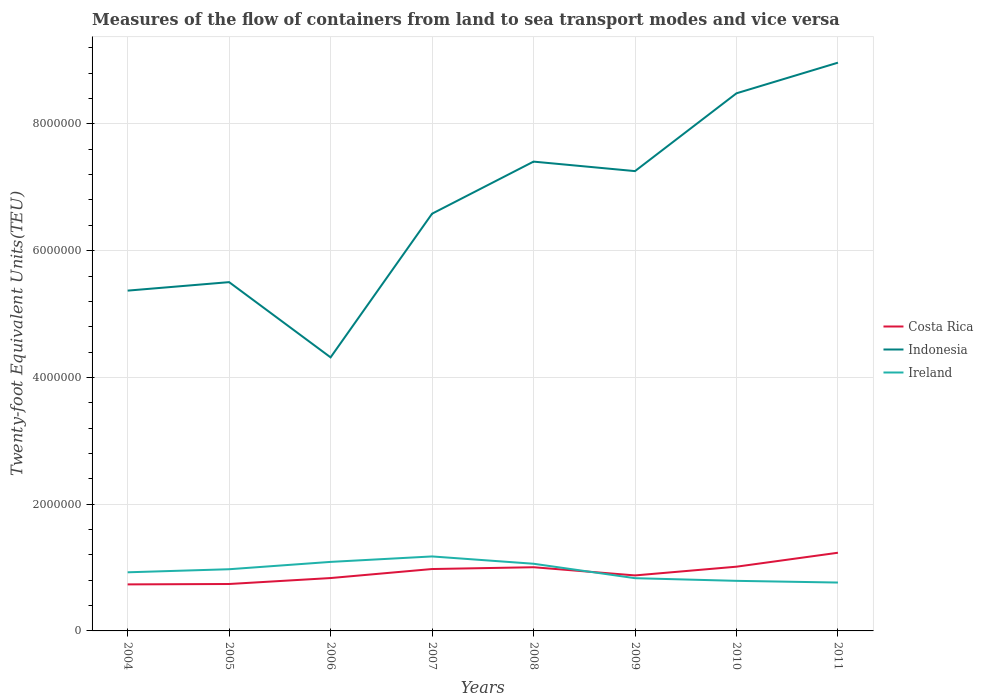How many different coloured lines are there?
Make the answer very short. 3. Across all years, what is the maximum container port traffic in Ireland?
Provide a succinct answer. 7.63e+05. In which year was the container port traffic in Indonesia maximum?
Your response must be concise. 2006. What is the total container port traffic in Indonesia in the graph?
Give a very brief answer. -2.27e+06. What is the difference between the highest and the second highest container port traffic in Indonesia?
Provide a short and direct response. 4.65e+06. What is the difference between the highest and the lowest container port traffic in Indonesia?
Give a very brief answer. 4. How many years are there in the graph?
Offer a terse response. 8. What is the difference between two consecutive major ticks on the Y-axis?
Make the answer very short. 2.00e+06. Does the graph contain grids?
Ensure brevity in your answer.  Yes. Where does the legend appear in the graph?
Provide a succinct answer. Center right. How many legend labels are there?
Offer a very short reply. 3. How are the legend labels stacked?
Keep it short and to the point. Vertical. What is the title of the graph?
Offer a terse response. Measures of the flow of containers from land to sea transport modes and vice versa. Does "Colombia" appear as one of the legend labels in the graph?
Offer a terse response. No. What is the label or title of the X-axis?
Your answer should be compact. Years. What is the label or title of the Y-axis?
Your answer should be compact. Twenty-foot Equivalent Units(TEU). What is the Twenty-foot Equivalent Units(TEU) of Costa Rica in 2004?
Ensure brevity in your answer.  7.34e+05. What is the Twenty-foot Equivalent Units(TEU) of Indonesia in 2004?
Offer a terse response. 5.37e+06. What is the Twenty-foot Equivalent Units(TEU) in Ireland in 2004?
Make the answer very short. 9.25e+05. What is the Twenty-foot Equivalent Units(TEU) in Costa Rica in 2005?
Offer a terse response. 7.40e+05. What is the Twenty-foot Equivalent Units(TEU) in Indonesia in 2005?
Offer a terse response. 5.50e+06. What is the Twenty-foot Equivalent Units(TEU) in Ireland in 2005?
Make the answer very short. 9.73e+05. What is the Twenty-foot Equivalent Units(TEU) of Costa Rica in 2006?
Offer a terse response. 8.34e+05. What is the Twenty-foot Equivalent Units(TEU) of Indonesia in 2006?
Your response must be concise. 4.32e+06. What is the Twenty-foot Equivalent Units(TEU) of Ireland in 2006?
Offer a terse response. 1.09e+06. What is the Twenty-foot Equivalent Units(TEU) of Costa Rica in 2007?
Your answer should be compact. 9.77e+05. What is the Twenty-foot Equivalent Units(TEU) in Indonesia in 2007?
Offer a terse response. 6.58e+06. What is the Twenty-foot Equivalent Units(TEU) of Ireland in 2007?
Keep it short and to the point. 1.18e+06. What is the Twenty-foot Equivalent Units(TEU) of Costa Rica in 2008?
Make the answer very short. 1.00e+06. What is the Twenty-foot Equivalent Units(TEU) in Indonesia in 2008?
Make the answer very short. 7.40e+06. What is the Twenty-foot Equivalent Units(TEU) in Ireland in 2008?
Offer a very short reply. 1.06e+06. What is the Twenty-foot Equivalent Units(TEU) of Costa Rica in 2009?
Offer a terse response. 8.76e+05. What is the Twenty-foot Equivalent Units(TEU) in Indonesia in 2009?
Keep it short and to the point. 7.26e+06. What is the Twenty-foot Equivalent Units(TEU) of Ireland in 2009?
Make the answer very short. 8.32e+05. What is the Twenty-foot Equivalent Units(TEU) in Costa Rica in 2010?
Make the answer very short. 1.01e+06. What is the Twenty-foot Equivalent Units(TEU) in Indonesia in 2010?
Make the answer very short. 8.48e+06. What is the Twenty-foot Equivalent Units(TEU) of Ireland in 2010?
Your answer should be very brief. 7.90e+05. What is the Twenty-foot Equivalent Units(TEU) of Costa Rica in 2011?
Make the answer very short. 1.23e+06. What is the Twenty-foot Equivalent Units(TEU) of Indonesia in 2011?
Provide a succinct answer. 8.97e+06. What is the Twenty-foot Equivalent Units(TEU) in Ireland in 2011?
Provide a succinct answer. 7.63e+05. Across all years, what is the maximum Twenty-foot Equivalent Units(TEU) in Costa Rica?
Your answer should be compact. 1.23e+06. Across all years, what is the maximum Twenty-foot Equivalent Units(TEU) of Indonesia?
Give a very brief answer. 8.97e+06. Across all years, what is the maximum Twenty-foot Equivalent Units(TEU) of Ireland?
Your answer should be very brief. 1.18e+06. Across all years, what is the minimum Twenty-foot Equivalent Units(TEU) in Costa Rica?
Offer a very short reply. 7.34e+05. Across all years, what is the minimum Twenty-foot Equivalent Units(TEU) in Indonesia?
Make the answer very short. 4.32e+06. Across all years, what is the minimum Twenty-foot Equivalent Units(TEU) in Ireland?
Ensure brevity in your answer.  7.63e+05. What is the total Twenty-foot Equivalent Units(TEU) in Costa Rica in the graph?
Keep it short and to the point. 7.41e+06. What is the total Twenty-foot Equivalent Units(TEU) of Indonesia in the graph?
Ensure brevity in your answer.  5.39e+07. What is the total Twenty-foot Equivalent Units(TEU) in Ireland in the graph?
Keep it short and to the point. 7.61e+06. What is the difference between the Twenty-foot Equivalent Units(TEU) of Costa Rica in 2004 and that in 2005?
Provide a short and direct response. -6332. What is the difference between the Twenty-foot Equivalent Units(TEU) in Indonesia in 2004 and that in 2005?
Provide a short and direct response. -1.34e+05. What is the difference between the Twenty-foot Equivalent Units(TEU) of Ireland in 2004 and that in 2005?
Offer a very short reply. -4.84e+04. What is the difference between the Twenty-foot Equivalent Units(TEU) in Costa Rica in 2004 and that in 2006?
Provide a short and direct response. -1.00e+05. What is the difference between the Twenty-foot Equivalent Units(TEU) of Indonesia in 2004 and that in 2006?
Provide a short and direct response. 1.05e+06. What is the difference between the Twenty-foot Equivalent Units(TEU) of Ireland in 2004 and that in 2006?
Keep it short and to the point. -1.64e+05. What is the difference between the Twenty-foot Equivalent Units(TEU) in Costa Rica in 2004 and that in 2007?
Offer a very short reply. -2.43e+05. What is the difference between the Twenty-foot Equivalent Units(TEU) of Indonesia in 2004 and that in 2007?
Your response must be concise. -1.21e+06. What is the difference between the Twenty-foot Equivalent Units(TEU) of Ireland in 2004 and that in 2007?
Keep it short and to the point. -2.50e+05. What is the difference between the Twenty-foot Equivalent Units(TEU) of Costa Rica in 2004 and that in 2008?
Give a very brief answer. -2.71e+05. What is the difference between the Twenty-foot Equivalent Units(TEU) in Indonesia in 2004 and that in 2008?
Make the answer very short. -2.04e+06. What is the difference between the Twenty-foot Equivalent Units(TEU) of Ireland in 2004 and that in 2008?
Your answer should be compact. -1.35e+05. What is the difference between the Twenty-foot Equivalent Units(TEU) of Costa Rica in 2004 and that in 2009?
Your answer should be very brief. -1.42e+05. What is the difference between the Twenty-foot Equivalent Units(TEU) in Indonesia in 2004 and that in 2009?
Ensure brevity in your answer.  -1.89e+06. What is the difference between the Twenty-foot Equivalent Units(TEU) of Ireland in 2004 and that in 2009?
Provide a short and direct response. 9.29e+04. What is the difference between the Twenty-foot Equivalent Units(TEU) in Costa Rica in 2004 and that in 2010?
Provide a succinct answer. -2.79e+05. What is the difference between the Twenty-foot Equivalent Units(TEU) of Indonesia in 2004 and that in 2010?
Ensure brevity in your answer.  -3.11e+06. What is the difference between the Twenty-foot Equivalent Units(TEU) of Ireland in 2004 and that in 2010?
Your answer should be compact. 1.35e+05. What is the difference between the Twenty-foot Equivalent Units(TEU) in Costa Rica in 2004 and that in 2011?
Provide a short and direct response. -4.99e+05. What is the difference between the Twenty-foot Equivalent Units(TEU) of Indonesia in 2004 and that in 2011?
Your answer should be compact. -3.60e+06. What is the difference between the Twenty-foot Equivalent Units(TEU) in Ireland in 2004 and that in 2011?
Make the answer very short. 1.62e+05. What is the difference between the Twenty-foot Equivalent Units(TEU) in Costa Rica in 2005 and that in 2006?
Give a very brief answer. -9.39e+04. What is the difference between the Twenty-foot Equivalent Units(TEU) of Indonesia in 2005 and that in 2006?
Make the answer very short. 1.19e+06. What is the difference between the Twenty-foot Equivalent Units(TEU) of Ireland in 2005 and that in 2006?
Keep it short and to the point. -1.16e+05. What is the difference between the Twenty-foot Equivalent Units(TEU) of Costa Rica in 2005 and that in 2007?
Give a very brief answer. -2.36e+05. What is the difference between the Twenty-foot Equivalent Units(TEU) in Indonesia in 2005 and that in 2007?
Your response must be concise. -1.08e+06. What is the difference between the Twenty-foot Equivalent Units(TEU) in Ireland in 2005 and that in 2007?
Your answer should be compact. -2.02e+05. What is the difference between the Twenty-foot Equivalent Units(TEU) in Costa Rica in 2005 and that in 2008?
Make the answer very short. -2.65e+05. What is the difference between the Twenty-foot Equivalent Units(TEU) in Indonesia in 2005 and that in 2008?
Your answer should be compact. -1.90e+06. What is the difference between the Twenty-foot Equivalent Units(TEU) of Ireland in 2005 and that in 2008?
Give a very brief answer. -8.67e+04. What is the difference between the Twenty-foot Equivalent Units(TEU) of Costa Rica in 2005 and that in 2009?
Keep it short and to the point. -1.35e+05. What is the difference between the Twenty-foot Equivalent Units(TEU) in Indonesia in 2005 and that in 2009?
Ensure brevity in your answer.  -1.75e+06. What is the difference between the Twenty-foot Equivalent Units(TEU) in Ireland in 2005 and that in 2009?
Provide a succinct answer. 1.41e+05. What is the difference between the Twenty-foot Equivalent Units(TEU) in Costa Rica in 2005 and that in 2010?
Your answer should be very brief. -2.73e+05. What is the difference between the Twenty-foot Equivalent Units(TEU) in Indonesia in 2005 and that in 2010?
Ensure brevity in your answer.  -2.98e+06. What is the difference between the Twenty-foot Equivalent Units(TEU) in Ireland in 2005 and that in 2010?
Your answer should be compact. 1.83e+05. What is the difference between the Twenty-foot Equivalent Units(TEU) of Costa Rica in 2005 and that in 2011?
Provide a short and direct response. -4.93e+05. What is the difference between the Twenty-foot Equivalent Units(TEU) in Indonesia in 2005 and that in 2011?
Offer a very short reply. -3.46e+06. What is the difference between the Twenty-foot Equivalent Units(TEU) of Ireland in 2005 and that in 2011?
Provide a short and direct response. 2.10e+05. What is the difference between the Twenty-foot Equivalent Units(TEU) of Costa Rica in 2006 and that in 2007?
Your response must be concise. -1.42e+05. What is the difference between the Twenty-foot Equivalent Units(TEU) in Indonesia in 2006 and that in 2007?
Provide a short and direct response. -2.27e+06. What is the difference between the Twenty-foot Equivalent Units(TEU) of Ireland in 2006 and that in 2007?
Ensure brevity in your answer.  -8.59e+04. What is the difference between the Twenty-foot Equivalent Units(TEU) in Costa Rica in 2006 and that in 2008?
Your answer should be very brief. -1.71e+05. What is the difference between the Twenty-foot Equivalent Units(TEU) of Indonesia in 2006 and that in 2008?
Ensure brevity in your answer.  -3.09e+06. What is the difference between the Twenty-foot Equivalent Units(TEU) of Ireland in 2006 and that in 2008?
Provide a succinct answer. 2.93e+04. What is the difference between the Twenty-foot Equivalent Units(TEU) of Costa Rica in 2006 and that in 2009?
Ensure brevity in your answer.  -4.14e+04. What is the difference between the Twenty-foot Equivalent Units(TEU) of Indonesia in 2006 and that in 2009?
Your answer should be compact. -2.94e+06. What is the difference between the Twenty-foot Equivalent Units(TEU) in Ireland in 2006 and that in 2009?
Provide a short and direct response. 2.57e+05. What is the difference between the Twenty-foot Equivalent Units(TEU) in Costa Rica in 2006 and that in 2010?
Provide a succinct answer. -1.79e+05. What is the difference between the Twenty-foot Equivalent Units(TEU) in Indonesia in 2006 and that in 2010?
Offer a very short reply. -4.17e+06. What is the difference between the Twenty-foot Equivalent Units(TEU) in Ireland in 2006 and that in 2010?
Make the answer very short. 2.99e+05. What is the difference between the Twenty-foot Equivalent Units(TEU) of Costa Rica in 2006 and that in 2011?
Keep it short and to the point. -3.99e+05. What is the difference between the Twenty-foot Equivalent Units(TEU) in Indonesia in 2006 and that in 2011?
Make the answer very short. -4.65e+06. What is the difference between the Twenty-foot Equivalent Units(TEU) of Ireland in 2006 and that in 2011?
Keep it short and to the point. 3.26e+05. What is the difference between the Twenty-foot Equivalent Units(TEU) in Costa Rica in 2007 and that in 2008?
Offer a terse response. -2.84e+04. What is the difference between the Twenty-foot Equivalent Units(TEU) of Indonesia in 2007 and that in 2008?
Make the answer very short. -8.22e+05. What is the difference between the Twenty-foot Equivalent Units(TEU) of Ireland in 2007 and that in 2008?
Your answer should be compact. 1.15e+05. What is the difference between the Twenty-foot Equivalent Units(TEU) of Costa Rica in 2007 and that in 2009?
Provide a short and direct response. 1.01e+05. What is the difference between the Twenty-foot Equivalent Units(TEU) of Indonesia in 2007 and that in 2009?
Give a very brief answer. -6.72e+05. What is the difference between the Twenty-foot Equivalent Units(TEU) of Ireland in 2007 and that in 2009?
Keep it short and to the point. 3.43e+05. What is the difference between the Twenty-foot Equivalent Units(TEU) of Costa Rica in 2007 and that in 2010?
Your answer should be compact. -3.69e+04. What is the difference between the Twenty-foot Equivalent Units(TEU) of Indonesia in 2007 and that in 2010?
Your response must be concise. -1.90e+06. What is the difference between the Twenty-foot Equivalent Units(TEU) in Ireland in 2007 and that in 2010?
Make the answer very short. 3.85e+05. What is the difference between the Twenty-foot Equivalent Units(TEU) in Costa Rica in 2007 and that in 2011?
Make the answer very short. -2.57e+05. What is the difference between the Twenty-foot Equivalent Units(TEU) of Indonesia in 2007 and that in 2011?
Provide a short and direct response. -2.38e+06. What is the difference between the Twenty-foot Equivalent Units(TEU) in Ireland in 2007 and that in 2011?
Keep it short and to the point. 4.12e+05. What is the difference between the Twenty-foot Equivalent Units(TEU) of Costa Rica in 2008 and that in 2009?
Offer a terse response. 1.29e+05. What is the difference between the Twenty-foot Equivalent Units(TEU) of Indonesia in 2008 and that in 2009?
Your answer should be compact. 1.50e+05. What is the difference between the Twenty-foot Equivalent Units(TEU) of Ireland in 2008 and that in 2009?
Your answer should be very brief. 2.28e+05. What is the difference between the Twenty-foot Equivalent Units(TEU) of Costa Rica in 2008 and that in 2010?
Make the answer very short. -8512. What is the difference between the Twenty-foot Equivalent Units(TEU) in Indonesia in 2008 and that in 2010?
Provide a short and direct response. -1.08e+06. What is the difference between the Twenty-foot Equivalent Units(TEU) of Ireland in 2008 and that in 2010?
Your response must be concise. 2.70e+05. What is the difference between the Twenty-foot Equivalent Units(TEU) of Costa Rica in 2008 and that in 2011?
Make the answer very short. -2.28e+05. What is the difference between the Twenty-foot Equivalent Units(TEU) in Indonesia in 2008 and that in 2011?
Offer a very short reply. -1.56e+06. What is the difference between the Twenty-foot Equivalent Units(TEU) in Ireland in 2008 and that in 2011?
Your response must be concise. 2.97e+05. What is the difference between the Twenty-foot Equivalent Units(TEU) in Costa Rica in 2009 and that in 2010?
Provide a succinct answer. -1.38e+05. What is the difference between the Twenty-foot Equivalent Units(TEU) of Indonesia in 2009 and that in 2010?
Provide a succinct answer. -1.23e+06. What is the difference between the Twenty-foot Equivalent Units(TEU) in Ireland in 2009 and that in 2010?
Ensure brevity in your answer.  4.20e+04. What is the difference between the Twenty-foot Equivalent Units(TEU) of Costa Rica in 2009 and that in 2011?
Make the answer very short. -3.58e+05. What is the difference between the Twenty-foot Equivalent Units(TEU) in Indonesia in 2009 and that in 2011?
Your answer should be very brief. -1.71e+06. What is the difference between the Twenty-foot Equivalent Units(TEU) of Ireland in 2009 and that in 2011?
Keep it short and to the point. 6.87e+04. What is the difference between the Twenty-foot Equivalent Units(TEU) of Costa Rica in 2010 and that in 2011?
Your answer should be compact. -2.20e+05. What is the difference between the Twenty-foot Equivalent Units(TEU) of Indonesia in 2010 and that in 2011?
Provide a short and direct response. -4.84e+05. What is the difference between the Twenty-foot Equivalent Units(TEU) of Ireland in 2010 and that in 2011?
Offer a very short reply. 2.68e+04. What is the difference between the Twenty-foot Equivalent Units(TEU) in Costa Rica in 2004 and the Twenty-foot Equivalent Units(TEU) in Indonesia in 2005?
Your answer should be very brief. -4.77e+06. What is the difference between the Twenty-foot Equivalent Units(TEU) of Costa Rica in 2004 and the Twenty-foot Equivalent Units(TEU) of Ireland in 2005?
Make the answer very short. -2.39e+05. What is the difference between the Twenty-foot Equivalent Units(TEU) in Indonesia in 2004 and the Twenty-foot Equivalent Units(TEU) in Ireland in 2005?
Give a very brief answer. 4.40e+06. What is the difference between the Twenty-foot Equivalent Units(TEU) in Costa Rica in 2004 and the Twenty-foot Equivalent Units(TEU) in Indonesia in 2006?
Provide a short and direct response. -3.58e+06. What is the difference between the Twenty-foot Equivalent Units(TEU) in Costa Rica in 2004 and the Twenty-foot Equivalent Units(TEU) in Ireland in 2006?
Your answer should be very brief. -3.55e+05. What is the difference between the Twenty-foot Equivalent Units(TEU) in Indonesia in 2004 and the Twenty-foot Equivalent Units(TEU) in Ireland in 2006?
Your response must be concise. 4.28e+06. What is the difference between the Twenty-foot Equivalent Units(TEU) in Costa Rica in 2004 and the Twenty-foot Equivalent Units(TEU) in Indonesia in 2007?
Ensure brevity in your answer.  -5.85e+06. What is the difference between the Twenty-foot Equivalent Units(TEU) of Costa Rica in 2004 and the Twenty-foot Equivalent Units(TEU) of Ireland in 2007?
Give a very brief answer. -4.41e+05. What is the difference between the Twenty-foot Equivalent Units(TEU) of Indonesia in 2004 and the Twenty-foot Equivalent Units(TEU) of Ireland in 2007?
Provide a short and direct response. 4.19e+06. What is the difference between the Twenty-foot Equivalent Units(TEU) of Costa Rica in 2004 and the Twenty-foot Equivalent Units(TEU) of Indonesia in 2008?
Ensure brevity in your answer.  -6.67e+06. What is the difference between the Twenty-foot Equivalent Units(TEU) in Costa Rica in 2004 and the Twenty-foot Equivalent Units(TEU) in Ireland in 2008?
Give a very brief answer. -3.26e+05. What is the difference between the Twenty-foot Equivalent Units(TEU) of Indonesia in 2004 and the Twenty-foot Equivalent Units(TEU) of Ireland in 2008?
Your answer should be very brief. 4.31e+06. What is the difference between the Twenty-foot Equivalent Units(TEU) in Costa Rica in 2004 and the Twenty-foot Equivalent Units(TEU) in Indonesia in 2009?
Your answer should be very brief. -6.52e+06. What is the difference between the Twenty-foot Equivalent Units(TEU) in Costa Rica in 2004 and the Twenty-foot Equivalent Units(TEU) in Ireland in 2009?
Offer a terse response. -9.79e+04. What is the difference between the Twenty-foot Equivalent Units(TEU) in Indonesia in 2004 and the Twenty-foot Equivalent Units(TEU) in Ireland in 2009?
Ensure brevity in your answer.  4.54e+06. What is the difference between the Twenty-foot Equivalent Units(TEU) of Costa Rica in 2004 and the Twenty-foot Equivalent Units(TEU) of Indonesia in 2010?
Make the answer very short. -7.75e+06. What is the difference between the Twenty-foot Equivalent Units(TEU) of Costa Rica in 2004 and the Twenty-foot Equivalent Units(TEU) of Ireland in 2010?
Your response must be concise. -5.60e+04. What is the difference between the Twenty-foot Equivalent Units(TEU) of Indonesia in 2004 and the Twenty-foot Equivalent Units(TEU) of Ireland in 2010?
Keep it short and to the point. 4.58e+06. What is the difference between the Twenty-foot Equivalent Units(TEU) in Costa Rica in 2004 and the Twenty-foot Equivalent Units(TEU) in Indonesia in 2011?
Offer a terse response. -8.23e+06. What is the difference between the Twenty-foot Equivalent Units(TEU) of Costa Rica in 2004 and the Twenty-foot Equivalent Units(TEU) of Ireland in 2011?
Your response must be concise. -2.92e+04. What is the difference between the Twenty-foot Equivalent Units(TEU) of Indonesia in 2004 and the Twenty-foot Equivalent Units(TEU) of Ireland in 2011?
Provide a succinct answer. 4.61e+06. What is the difference between the Twenty-foot Equivalent Units(TEU) of Costa Rica in 2005 and the Twenty-foot Equivalent Units(TEU) of Indonesia in 2006?
Keep it short and to the point. -3.58e+06. What is the difference between the Twenty-foot Equivalent Units(TEU) in Costa Rica in 2005 and the Twenty-foot Equivalent Units(TEU) in Ireland in 2006?
Ensure brevity in your answer.  -3.49e+05. What is the difference between the Twenty-foot Equivalent Units(TEU) of Indonesia in 2005 and the Twenty-foot Equivalent Units(TEU) of Ireland in 2006?
Keep it short and to the point. 4.41e+06. What is the difference between the Twenty-foot Equivalent Units(TEU) of Costa Rica in 2005 and the Twenty-foot Equivalent Units(TEU) of Indonesia in 2007?
Your response must be concise. -5.84e+06. What is the difference between the Twenty-foot Equivalent Units(TEU) in Costa Rica in 2005 and the Twenty-foot Equivalent Units(TEU) in Ireland in 2007?
Offer a very short reply. -4.35e+05. What is the difference between the Twenty-foot Equivalent Units(TEU) in Indonesia in 2005 and the Twenty-foot Equivalent Units(TEU) in Ireland in 2007?
Offer a terse response. 4.33e+06. What is the difference between the Twenty-foot Equivalent Units(TEU) of Costa Rica in 2005 and the Twenty-foot Equivalent Units(TEU) of Indonesia in 2008?
Provide a short and direct response. -6.66e+06. What is the difference between the Twenty-foot Equivalent Units(TEU) of Costa Rica in 2005 and the Twenty-foot Equivalent Units(TEU) of Ireland in 2008?
Your answer should be very brief. -3.20e+05. What is the difference between the Twenty-foot Equivalent Units(TEU) in Indonesia in 2005 and the Twenty-foot Equivalent Units(TEU) in Ireland in 2008?
Provide a succinct answer. 4.44e+06. What is the difference between the Twenty-foot Equivalent Units(TEU) in Costa Rica in 2005 and the Twenty-foot Equivalent Units(TEU) in Indonesia in 2009?
Ensure brevity in your answer.  -6.51e+06. What is the difference between the Twenty-foot Equivalent Units(TEU) of Costa Rica in 2005 and the Twenty-foot Equivalent Units(TEU) of Ireland in 2009?
Your answer should be very brief. -9.16e+04. What is the difference between the Twenty-foot Equivalent Units(TEU) of Indonesia in 2005 and the Twenty-foot Equivalent Units(TEU) of Ireland in 2009?
Make the answer very short. 4.67e+06. What is the difference between the Twenty-foot Equivalent Units(TEU) of Costa Rica in 2005 and the Twenty-foot Equivalent Units(TEU) of Indonesia in 2010?
Provide a short and direct response. -7.74e+06. What is the difference between the Twenty-foot Equivalent Units(TEU) of Costa Rica in 2005 and the Twenty-foot Equivalent Units(TEU) of Ireland in 2010?
Offer a terse response. -4.96e+04. What is the difference between the Twenty-foot Equivalent Units(TEU) in Indonesia in 2005 and the Twenty-foot Equivalent Units(TEU) in Ireland in 2010?
Offer a terse response. 4.71e+06. What is the difference between the Twenty-foot Equivalent Units(TEU) in Costa Rica in 2005 and the Twenty-foot Equivalent Units(TEU) in Indonesia in 2011?
Your response must be concise. -8.23e+06. What is the difference between the Twenty-foot Equivalent Units(TEU) of Costa Rica in 2005 and the Twenty-foot Equivalent Units(TEU) of Ireland in 2011?
Keep it short and to the point. -2.29e+04. What is the difference between the Twenty-foot Equivalent Units(TEU) in Indonesia in 2005 and the Twenty-foot Equivalent Units(TEU) in Ireland in 2011?
Provide a short and direct response. 4.74e+06. What is the difference between the Twenty-foot Equivalent Units(TEU) in Costa Rica in 2006 and the Twenty-foot Equivalent Units(TEU) in Indonesia in 2007?
Your answer should be very brief. -5.75e+06. What is the difference between the Twenty-foot Equivalent Units(TEU) of Costa Rica in 2006 and the Twenty-foot Equivalent Units(TEU) of Ireland in 2007?
Provide a short and direct response. -3.41e+05. What is the difference between the Twenty-foot Equivalent Units(TEU) in Indonesia in 2006 and the Twenty-foot Equivalent Units(TEU) in Ireland in 2007?
Your answer should be compact. 3.14e+06. What is the difference between the Twenty-foot Equivalent Units(TEU) of Costa Rica in 2006 and the Twenty-foot Equivalent Units(TEU) of Indonesia in 2008?
Make the answer very short. -6.57e+06. What is the difference between the Twenty-foot Equivalent Units(TEU) of Costa Rica in 2006 and the Twenty-foot Equivalent Units(TEU) of Ireland in 2008?
Your response must be concise. -2.26e+05. What is the difference between the Twenty-foot Equivalent Units(TEU) of Indonesia in 2006 and the Twenty-foot Equivalent Units(TEU) of Ireland in 2008?
Your answer should be very brief. 3.26e+06. What is the difference between the Twenty-foot Equivalent Units(TEU) of Costa Rica in 2006 and the Twenty-foot Equivalent Units(TEU) of Indonesia in 2009?
Your answer should be compact. -6.42e+06. What is the difference between the Twenty-foot Equivalent Units(TEU) in Costa Rica in 2006 and the Twenty-foot Equivalent Units(TEU) in Ireland in 2009?
Provide a succinct answer. 2299.19. What is the difference between the Twenty-foot Equivalent Units(TEU) in Indonesia in 2006 and the Twenty-foot Equivalent Units(TEU) in Ireland in 2009?
Ensure brevity in your answer.  3.48e+06. What is the difference between the Twenty-foot Equivalent Units(TEU) of Costa Rica in 2006 and the Twenty-foot Equivalent Units(TEU) of Indonesia in 2010?
Ensure brevity in your answer.  -7.65e+06. What is the difference between the Twenty-foot Equivalent Units(TEU) of Costa Rica in 2006 and the Twenty-foot Equivalent Units(TEU) of Ireland in 2010?
Make the answer very short. 4.43e+04. What is the difference between the Twenty-foot Equivalent Units(TEU) in Indonesia in 2006 and the Twenty-foot Equivalent Units(TEU) in Ireland in 2010?
Provide a short and direct response. 3.53e+06. What is the difference between the Twenty-foot Equivalent Units(TEU) of Costa Rica in 2006 and the Twenty-foot Equivalent Units(TEU) of Indonesia in 2011?
Keep it short and to the point. -8.13e+06. What is the difference between the Twenty-foot Equivalent Units(TEU) in Costa Rica in 2006 and the Twenty-foot Equivalent Units(TEU) in Ireland in 2011?
Your answer should be compact. 7.10e+04. What is the difference between the Twenty-foot Equivalent Units(TEU) in Indonesia in 2006 and the Twenty-foot Equivalent Units(TEU) in Ireland in 2011?
Make the answer very short. 3.55e+06. What is the difference between the Twenty-foot Equivalent Units(TEU) of Costa Rica in 2007 and the Twenty-foot Equivalent Units(TEU) of Indonesia in 2008?
Ensure brevity in your answer.  -6.43e+06. What is the difference between the Twenty-foot Equivalent Units(TEU) of Costa Rica in 2007 and the Twenty-foot Equivalent Units(TEU) of Ireland in 2008?
Offer a terse response. -8.33e+04. What is the difference between the Twenty-foot Equivalent Units(TEU) of Indonesia in 2007 and the Twenty-foot Equivalent Units(TEU) of Ireland in 2008?
Provide a short and direct response. 5.52e+06. What is the difference between the Twenty-foot Equivalent Units(TEU) of Costa Rica in 2007 and the Twenty-foot Equivalent Units(TEU) of Indonesia in 2009?
Offer a very short reply. -6.28e+06. What is the difference between the Twenty-foot Equivalent Units(TEU) of Costa Rica in 2007 and the Twenty-foot Equivalent Units(TEU) of Ireland in 2009?
Offer a terse response. 1.45e+05. What is the difference between the Twenty-foot Equivalent Units(TEU) in Indonesia in 2007 and the Twenty-foot Equivalent Units(TEU) in Ireland in 2009?
Your response must be concise. 5.75e+06. What is the difference between the Twenty-foot Equivalent Units(TEU) of Costa Rica in 2007 and the Twenty-foot Equivalent Units(TEU) of Indonesia in 2010?
Your answer should be compact. -7.51e+06. What is the difference between the Twenty-foot Equivalent Units(TEU) in Costa Rica in 2007 and the Twenty-foot Equivalent Units(TEU) in Ireland in 2010?
Make the answer very short. 1.87e+05. What is the difference between the Twenty-foot Equivalent Units(TEU) in Indonesia in 2007 and the Twenty-foot Equivalent Units(TEU) in Ireland in 2010?
Your answer should be compact. 5.79e+06. What is the difference between the Twenty-foot Equivalent Units(TEU) of Costa Rica in 2007 and the Twenty-foot Equivalent Units(TEU) of Indonesia in 2011?
Offer a very short reply. -7.99e+06. What is the difference between the Twenty-foot Equivalent Units(TEU) in Costa Rica in 2007 and the Twenty-foot Equivalent Units(TEU) in Ireland in 2011?
Make the answer very short. 2.13e+05. What is the difference between the Twenty-foot Equivalent Units(TEU) of Indonesia in 2007 and the Twenty-foot Equivalent Units(TEU) of Ireland in 2011?
Provide a short and direct response. 5.82e+06. What is the difference between the Twenty-foot Equivalent Units(TEU) in Costa Rica in 2008 and the Twenty-foot Equivalent Units(TEU) in Indonesia in 2009?
Offer a terse response. -6.25e+06. What is the difference between the Twenty-foot Equivalent Units(TEU) of Costa Rica in 2008 and the Twenty-foot Equivalent Units(TEU) of Ireland in 2009?
Your answer should be compact. 1.73e+05. What is the difference between the Twenty-foot Equivalent Units(TEU) of Indonesia in 2008 and the Twenty-foot Equivalent Units(TEU) of Ireland in 2009?
Offer a terse response. 6.57e+06. What is the difference between the Twenty-foot Equivalent Units(TEU) of Costa Rica in 2008 and the Twenty-foot Equivalent Units(TEU) of Indonesia in 2010?
Make the answer very short. -7.48e+06. What is the difference between the Twenty-foot Equivalent Units(TEU) in Costa Rica in 2008 and the Twenty-foot Equivalent Units(TEU) in Ireland in 2010?
Your response must be concise. 2.15e+05. What is the difference between the Twenty-foot Equivalent Units(TEU) in Indonesia in 2008 and the Twenty-foot Equivalent Units(TEU) in Ireland in 2010?
Keep it short and to the point. 6.61e+06. What is the difference between the Twenty-foot Equivalent Units(TEU) of Costa Rica in 2008 and the Twenty-foot Equivalent Units(TEU) of Indonesia in 2011?
Ensure brevity in your answer.  -7.96e+06. What is the difference between the Twenty-foot Equivalent Units(TEU) in Costa Rica in 2008 and the Twenty-foot Equivalent Units(TEU) in Ireland in 2011?
Your answer should be compact. 2.42e+05. What is the difference between the Twenty-foot Equivalent Units(TEU) of Indonesia in 2008 and the Twenty-foot Equivalent Units(TEU) of Ireland in 2011?
Offer a very short reply. 6.64e+06. What is the difference between the Twenty-foot Equivalent Units(TEU) of Costa Rica in 2009 and the Twenty-foot Equivalent Units(TEU) of Indonesia in 2010?
Provide a succinct answer. -7.61e+06. What is the difference between the Twenty-foot Equivalent Units(TEU) in Costa Rica in 2009 and the Twenty-foot Equivalent Units(TEU) in Ireland in 2010?
Your response must be concise. 8.56e+04. What is the difference between the Twenty-foot Equivalent Units(TEU) of Indonesia in 2009 and the Twenty-foot Equivalent Units(TEU) of Ireland in 2010?
Offer a very short reply. 6.46e+06. What is the difference between the Twenty-foot Equivalent Units(TEU) in Costa Rica in 2009 and the Twenty-foot Equivalent Units(TEU) in Indonesia in 2011?
Give a very brief answer. -8.09e+06. What is the difference between the Twenty-foot Equivalent Units(TEU) in Costa Rica in 2009 and the Twenty-foot Equivalent Units(TEU) in Ireland in 2011?
Ensure brevity in your answer.  1.12e+05. What is the difference between the Twenty-foot Equivalent Units(TEU) of Indonesia in 2009 and the Twenty-foot Equivalent Units(TEU) of Ireland in 2011?
Keep it short and to the point. 6.49e+06. What is the difference between the Twenty-foot Equivalent Units(TEU) of Costa Rica in 2010 and the Twenty-foot Equivalent Units(TEU) of Indonesia in 2011?
Keep it short and to the point. -7.95e+06. What is the difference between the Twenty-foot Equivalent Units(TEU) in Costa Rica in 2010 and the Twenty-foot Equivalent Units(TEU) in Ireland in 2011?
Your response must be concise. 2.50e+05. What is the difference between the Twenty-foot Equivalent Units(TEU) of Indonesia in 2010 and the Twenty-foot Equivalent Units(TEU) of Ireland in 2011?
Provide a succinct answer. 7.72e+06. What is the average Twenty-foot Equivalent Units(TEU) of Costa Rica per year?
Ensure brevity in your answer.  9.27e+05. What is the average Twenty-foot Equivalent Units(TEU) in Indonesia per year?
Your answer should be very brief. 6.74e+06. What is the average Twenty-foot Equivalent Units(TEU) in Ireland per year?
Your response must be concise. 9.51e+05. In the year 2004, what is the difference between the Twenty-foot Equivalent Units(TEU) in Costa Rica and Twenty-foot Equivalent Units(TEU) in Indonesia?
Keep it short and to the point. -4.64e+06. In the year 2004, what is the difference between the Twenty-foot Equivalent Units(TEU) of Costa Rica and Twenty-foot Equivalent Units(TEU) of Ireland?
Provide a short and direct response. -1.91e+05. In the year 2004, what is the difference between the Twenty-foot Equivalent Units(TEU) of Indonesia and Twenty-foot Equivalent Units(TEU) of Ireland?
Provide a succinct answer. 4.44e+06. In the year 2005, what is the difference between the Twenty-foot Equivalent Units(TEU) in Costa Rica and Twenty-foot Equivalent Units(TEU) in Indonesia?
Provide a short and direct response. -4.76e+06. In the year 2005, what is the difference between the Twenty-foot Equivalent Units(TEU) in Costa Rica and Twenty-foot Equivalent Units(TEU) in Ireland?
Your answer should be very brief. -2.33e+05. In the year 2005, what is the difference between the Twenty-foot Equivalent Units(TEU) of Indonesia and Twenty-foot Equivalent Units(TEU) of Ireland?
Keep it short and to the point. 4.53e+06. In the year 2006, what is the difference between the Twenty-foot Equivalent Units(TEU) in Costa Rica and Twenty-foot Equivalent Units(TEU) in Indonesia?
Ensure brevity in your answer.  -3.48e+06. In the year 2006, what is the difference between the Twenty-foot Equivalent Units(TEU) of Costa Rica and Twenty-foot Equivalent Units(TEU) of Ireland?
Keep it short and to the point. -2.55e+05. In the year 2006, what is the difference between the Twenty-foot Equivalent Units(TEU) in Indonesia and Twenty-foot Equivalent Units(TEU) in Ireland?
Provide a short and direct response. 3.23e+06. In the year 2007, what is the difference between the Twenty-foot Equivalent Units(TEU) of Costa Rica and Twenty-foot Equivalent Units(TEU) of Indonesia?
Keep it short and to the point. -5.61e+06. In the year 2007, what is the difference between the Twenty-foot Equivalent Units(TEU) of Costa Rica and Twenty-foot Equivalent Units(TEU) of Ireland?
Your answer should be compact. -1.99e+05. In the year 2007, what is the difference between the Twenty-foot Equivalent Units(TEU) in Indonesia and Twenty-foot Equivalent Units(TEU) in Ireland?
Give a very brief answer. 5.41e+06. In the year 2008, what is the difference between the Twenty-foot Equivalent Units(TEU) of Costa Rica and Twenty-foot Equivalent Units(TEU) of Indonesia?
Keep it short and to the point. -6.40e+06. In the year 2008, what is the difference between the Twenty-foot Equivalent Units(TEU) of Costa Rica and Twenty-foot Equivalent Units(TEU) of Ireland?
Make the answer very short. -5.50e+04. In the year 2008, what is the difference between the Twenty-foot Equivalent Units(TEU) of Indonesia and Twenty-foot Equivalent Units(TEU) of Ireland?
Offer a terse response. 6.34e+06. In the year 2009, what is the difference between the Twenty-foot Equivalent Units(TEU) in Costa Rica and Twenty-foot Equivalent Units(TEU) in Indonesia?
Provide a succinct answer. -6.38e+06. In the year 2009, what is the difference between the Twenty-foot Equivalent Units(TEU) of Costa Rica and Twenty-foot Equivalent Units(TEU) of Ireland?
Provide a short and direct response. 4.37e+04. In the year 2009, what is the difference between the Twenty-foot Equivalent Units(TEU) in Indonesia and Twenty-foot Equivalent Units(TEU) in Ireland?
Provide a short and direct response. 6.42e+06. In the year 2010, what is the difference between the Twenty-foot Equivalent Units(TEU) of Costa Rica and Twenty-foot Equivalent Units(TEU) of Indonesia?
Provide a succinct answer. -7.47e+06. In the year 2010, what is the difference between the Twenty-foot Equivalent Units(TEU) of Costa Rica and Twenty-foot Equivalent Units(TEU) of Ireland?
Offer a terse response. 2.23e+05. In the year 2010, what is the difference between the Twenty-foot Equivalent Units(TEU) in Indonesia and Twenty-foot Equivalent Units(TEU) in Ireland?
Provide a succinct answer. 7.69e+06. In the year 2011, what is the difference between the Twenty-foot Equivalent Units(TEU) in Costa Rica and Twenty-foot Equivalent Units(TEU) in Indonesia?
Offer a very short reply. -7.73e+06. In the year 2011, what is the difference between the Twenty-foot Equivalent Units(TEU) in Costa Rica and Twenty-foot Equivalent Units(TEU) in Ireland?
Keep it short and to the point. 4.70e+05. In the year 2011, what is the difference between the Twenty-foot Equivalent Units(TEU) of Indonesia and Twenty-foot Equivalent Units(TEU) of Ireland?
Make the answer very short. 8.20e+06. What is the ratio of the Twenty-foot Equivalent Units(TEU) in Indonesia in 2004 to that in 2005?
Ensure brevity in your answer.  0.98. What is the ratio of the Twenty-foot Equivalent Units(TEU) of Ireland in 2004 to that in 2005?
Make the answer very short. 0.95. What is the ratio of the Twenty-foot Equivalent Units(TEU) of Costa Rica in 2004 to that in 2006?
Your answer should be compact. 0.88. What is the ratio of the Twenty-foot Equivalent Units(TEU) of Indonesia in 2004 to that in 2006?
Offer a very short reply. 1.24. What is the ratio of the Twenty-foot Equivalent Units(TEU) in Ireland in 2004 to that in 2006?
Your response must be concise. 0.85. What is the ratio of the Twenty-foot Equivalent Units(TEU) in Costa Rica in 2004 to that in 2007?
Offer a very short reply. 0.75. What is the ratio of the Twenty-foot Equivalent Units(TEU) in Indonesia in 2004 to that in 2007?
Make the answer very short. 0.82. What is the ratio of the Twenty-foot Equivalent Units(TEU) of Ireland in 2004 to that in 2007?
Ensure brevity in your answer.  0.79. What is the ratio of the Twenty-foot Equivalent Units(TEU) of Costa Rica in 2004 to that in 2008?
Provide a succinct answer. 0.73. What is the ratio of the Twenty-foot Equivalent Units(TEU) in Indonesia in 2004 to that in 2008?
Keep it short and to the point. 0.73. What is the ratio of the Twenty-foot Equivalent Units(TEU) in Ireland in 2004 to that in 2008?
Offer a very short reply. 0.87. What is the ratio of the Twenty-foot Equivalent Units(TEU) of Costa Rica in 2004 to that in 2009?
Ensure brevity in your answer.  0.84. What is the ratio of the Twenty-foot Equivalent Units(TEU) of Indonesia in 2004 to that in 2009?
Offer a very short reply. 0.74. What is the ratio of the Twenty-foot Equivalent Units(TEU) in Ireland in 2004 to that in 2009?
Offer a terse response. 1.11. What is the ratio of the Twenty-foot Equivalent Units(TEU) in Costa Rica in 2004 to that in 2010?
Your response must be concise. 0.72. What is the ratio of the Twenty-foot Equivalent Units(TEU) in Indonesia in 2004 to that in 2010?
Your answer should be compact. 0.63. What is the ratio of the Twenty-foot Equivalent Units(TEU) of Ireland in 2004 to that in 2010?
Your response must be concise. 1.17. What is the ratio of the Twenty-foot Equivalent Units(TEU) in Costa Rica in 2004 to that in 2011?
Keep it short and to the point. 0.6. What is the ratio of the Twenty-foot Equivalent Units(TEU) of Indonesia in 2004 to that in 2011?
Provide a short and direct response. 0.6. What is the ratio of the Twenty-foot Equivalent Units(TEU) of Ireland in 2004 to that in 2011?
Give a very brief answer. 1.21. What is the ratio of the Twenty-foot Equivalent Units(TEU) in Costa Rica in 2005 to that in 2006?
Make the answer very short. 0.89. What is the ratio of the Twenty-foot Equivalent Units(TEU) of Indonesia in 2005 to that in 2006?
Offer a very short reply. 1.27. What is the ratio of the Twenty-foot Equivalent Units(TEU) in Ireland in 2005 to that in 2006?
Provide a short and direct response. 0.89. What is the ratio of the Twenty-foot Equivalent Units(TEU) in Costa Rica in 2005 to that in 2007?
Provide a succinct answer. 0.76. What is the ratio of the Twenty-foot Equivalent Units(TEU) in Indonesia in 2005 to that in 2007?
Provide a short and direct response. 0.84. What is the ratio of the Twenty-foot Equivalent Units(TEU) of Ireland in 2005 to that in 2007?
Your answer should be very brief. 0.83. What is the ratio of the Twenty-foot Equivalent Units(TEU) in Costa Rica in 2005 to that in 2008?
Provide a short and direct response. 0.74. What is the ratio of the Twenty-foot Equivalent Units(TEU) of Indonesia in 2005 to that in 2008?
Ensure brevity in your answer.  0.74. What is the ratio of the Twenty-foot Equivalent Units(TEU) of Ireland in 2005 to that in 2008?
Your answer should be very brief. 0.92. What is the ratio of the Twenty-foot Equivalent Units(TEU) in Costa Rica in 2005 to that in 2009?
Your answer should be very brief. 0.85. What is the ratio of the Twenty-foot Equivalent Units(TEU) in Indonesia in 2005 to that in 2009?
Keep it short and to the point. 0.76. What is the ratio of the Twenty-foot Equivalent Units(TEU) in Ireland in 2005 to that in 2009?
Offer a very short reply. 1.17. What is the ratio of the Twenty-foot Equivalent Units(TEU) of Costa Rica in 2005 to that in 2010?
Your answer should be compact. 0.73. What is the ratio of the Twenty-foot Equivalent Units(TEU) in Indonesia in 2005 to that in 2010?
Ensure brevity in your answer.  0.65. What is the ratio of the Twenty-foot Equivalent Units(TEU) in Ireland in 2005 to that in 2010?
Keep it short and to the point. 1.23. What is the ratio of the Twenty-foot Equivalent Units(TEU) in Costa Rica in 2005 to that in 2011?
Your answer should be very brief. 0.6. What is the ratio of the Twenty-foot Equivalent Units(TEU) of Indonesia in 2005 to that in 2011?
Give a very brief answer. 0.61. What is the ratio of the Twenty-foot Equivalent Units(TEU) of Ireland in 2005 to that in 2011?
Your answer should be very brief. 1.28. What is the ratio of the Twenty-foot Equivalent Units(TEU) of Costa Rica in 2006 to that in 2007?
Offer a terse response. 0.85. What is the ratio of the Twenty-foot Equivalent Units(TEU) of Indonesia in 2006 to that in 2007?
Provide a short and direct response. 0.66. What is the ratio of the Twenty-foot Equivalent Units(TEU) of Ireland in 2006 to that in 2007?
Make the answer very short. 0.93. What is the ratio of the Twenty-foot Equivalent Units(TEU) of Costa Rica in 2006 to that in 2008?
Provide a short and direct response. 0.83. What is the ratio of the Twenty-foot Equivalent Units(TEU) of Indonesia in 2006 to that in 2008?
Make the answer very short. 0.58. What is the ratio of the Twenty-foot Equivalent Units(TEU) of Ireland in 2006 to that in 2008?
Your response must be concise. 1.03. What is the ratio of the Twenty-foot Equivalent Units(TEU) of Costa Rica in 2006 to that in 2009?
Keep it short and to the point. 0.95. What is the ratio of the Twenty-foot Equivalent Units(TEU) in Indonesia in 2006 to that in 2009?
Your answer should be compact. 0.59. What is the ratio of the Twenty-foot Equivalent Units(TEU) in Ireland in 2006 to that in 2009?
Provide a short and direct response. 1.31. What is the ratio of the Twenty-foot Equivalent Units(TEU) in Costa Rica in 2006 to that in 2010?
Provide a succinct answer. 0.82. What is the ratio of the Twenty-foot Equivalent Units(TEU) in Indonesia in 2006 to that in 2010?
Keep it short and to the point. 0.51. What is the ratio of the Twenty-foot Equivalent Units(TEU) in Ireland in 2006 to that in 2010?
Provide a short and direct response. 1.38. What is the ratio of the Twenty-foot Equivalent Units(TEU) in Costa Rica in 2006 to that in 2011?
Provide a succinct answer. 0.68. What is the ratio of the Twenty-foot Equivalent Units(TEU) of Indonesia in 2006 to that in 2011?
Give a very brief answer. 0.48. What is the ratio of the Twenty-foot Equivalent Units(TEU) in Ireland in 2006 to that in 2011?
Offer a terse response. 1.43. What is the ratio of the Twenty-foot Equivalent Units(TEU) of Costa Rica in 2007 to that in 2008?
Provide a succinct answer. 0.97. What is the ratio of the Twenty-foot Equivalent Units(TEU) of Indonesia in 2007 to that in 2008?
Your answer should be compact. 0.89. What is the ratio of the Twenty-foot Equivalent Units(TEU) of Ireland in 2007 to that in 2008?
Your answer should be compact. 1.11. What is the ratio of the Twenty-foot Equivalent Units(TEU) in Costa Rica in 2007 to that in 2009?
Provide a short and direct response. 1.12. What is the ratio of the Twenty-foot Equivalent Units(TEU) of Indonesia in 2007 to that in 2009?
Give a very brief answer. 0.91. What is the ratio of the Twenty-foot Equivalent Units(TEU) of Ireland in 2007 to that in 2009?
Offer a very short reply. 1.41. What is the ratio of the Twenty-foot Equivalent Units(TEU) of Costa Rica in 2007 to that in 2010?
Your response must be concise. 0.96. What is the ratio of the Twenty-foot Equivalent Units(TEU) in Indonesia in 2007 to that in 2010?
Provide a short and direct response. 0.78. What is the ratio of the Twenty-foot Equivalent Units(TEU) of Ireland in 2007 to that in 2010?
Your response must be concise. 1.49. What is the ratio of the Twenty-foot Equivalent Units(TEU) of Costa Rica in 2007 to that in 2011?
Your answer should be very brief. 0.79. What is the ratio of the Twenty-foot Equivalent Units(TEU) in Indonesia in 2007 to that in 2011?
Your answer should be very brief. 0.73. What is the ratio of the Twenty-foot Equivalent Units(TEU) of Ireland in 2007 to that in 2011?
Make the answer very short. 1.54. What is the ratio of the Twenty-foot Equivalent Units(TEU) in Costa Rica in 2008 to that in 2009?
Offer a very short reply. 1.15. What is the ratio of the Twenty-foot Equivalent Units(TEU) of Indonesia in 2008 to that in 2009?
Keep it short and to the point. 1.02. What is the ratio of the Twenty-foot Equivalent Units(TEU) of Ireland in 2008 to that in 2009?
Offer a very short reply. 1.27. What is the ratio of the Twenty-foot Equivalent Units(TEU) in Indonesia in 2008 to that in 2010?
Provide a short and direct response. 0.87. What is the ratio of the Twenty-foot Equivalent Units(TEU) of Ireland in 2008 to that in 2010?
Offer a very short reply. 1.34. What is the ratio of the Twenty-foot Equivalent Units(TEU) of Costa Rica in 2008 to that in 2011?
Give a very brief answer. 0.81. What is the ratio of the Twenty-foot Equivalent Units(TEU) of Indonesia in 2008 to that in 2011?
Keep it short and to the point. 0.83. What is the ratio of the Twenty-foot Equivalent Units(TEU) in Ireland in 2008 to that in 2011?
Your answer should be very brief. 1.39. What is the ratio of the Twenty-foot Equivalent Units(TEU) in Costa Rica in 2009 to that in 2010?
Ensure brevity in your answer.  0.86. What is the ratio of the Twenty-foot Equivalent Units(TEU) of Indonesia in 2009 to that in 2010?
Offer a terse response. 0.86. What is the ratio of the Twenty-foot Equivalent Units(TEU) of Ireland in 2009 to that in 2010?
Provide a short and direct response. 1.05. What is the ratio of the Twenty-foot Equivalent Units(TEU) of Costa Rica in 2009 to that in 2011?
Ensure brevity in your answer.  0.71. What is the ratio of the Twenty-foot Equivalent Units(TEU) of Indonesia in 2009 to that in 2011?
Provide a succinct answer. 0.81. What is the ratio of the Twenty-foot Equivalent Units(TEU) of Ireland in 2009 to that in 2011?
Make the answer very short. 1.09. What is the ratio of the Twenty-foot Equivalent Units(TEU) of Costa Rica in 2010 to that in 2011?
Your answer should be compact. 0.82. What is the ratio of the Twenty-foot Equivalent Units(TEU) of Indonesia in 2010 to that in 2011?
Your answer should be compact. 0.95. What is the ratio of the Twenty-foot Equivalent Units(TEU) in Ireland in 2010 to that in 2011?
Offer a terse response. 1.04. What is the difference between the highest and the second highest Twenty-foot Equivalent Units(TEU) in Costa Rica?
Your answer should be very brief. 2.20e+05. What is the difference between the highest and the second highest Twenty-foot Equivalent Units(TEU) of Indonesia?
Offer a very short reply. 4.84e+05. What is the difference between the highest and the second highest Twenty-foot Equivalent Units(TEU) in Ireland?
Offer a terse response. 8.59e+04. What is the difference between the highest and the lowest Twenty-foot Equivalent Units(TEU) of Costa Rica?
Provide a short and direct response. 4.99e+05. What is the difference between the highest and the lowest Twenty-foot Equivalent Units(TEU) in Indonesia?
Your response must be concise. 4.65e+06. What is the difference between the highest and the lowest Twenty-foot Equivalent Units(TEU) in Ireland?
Keep it short and to the point. 4.12e+05. 